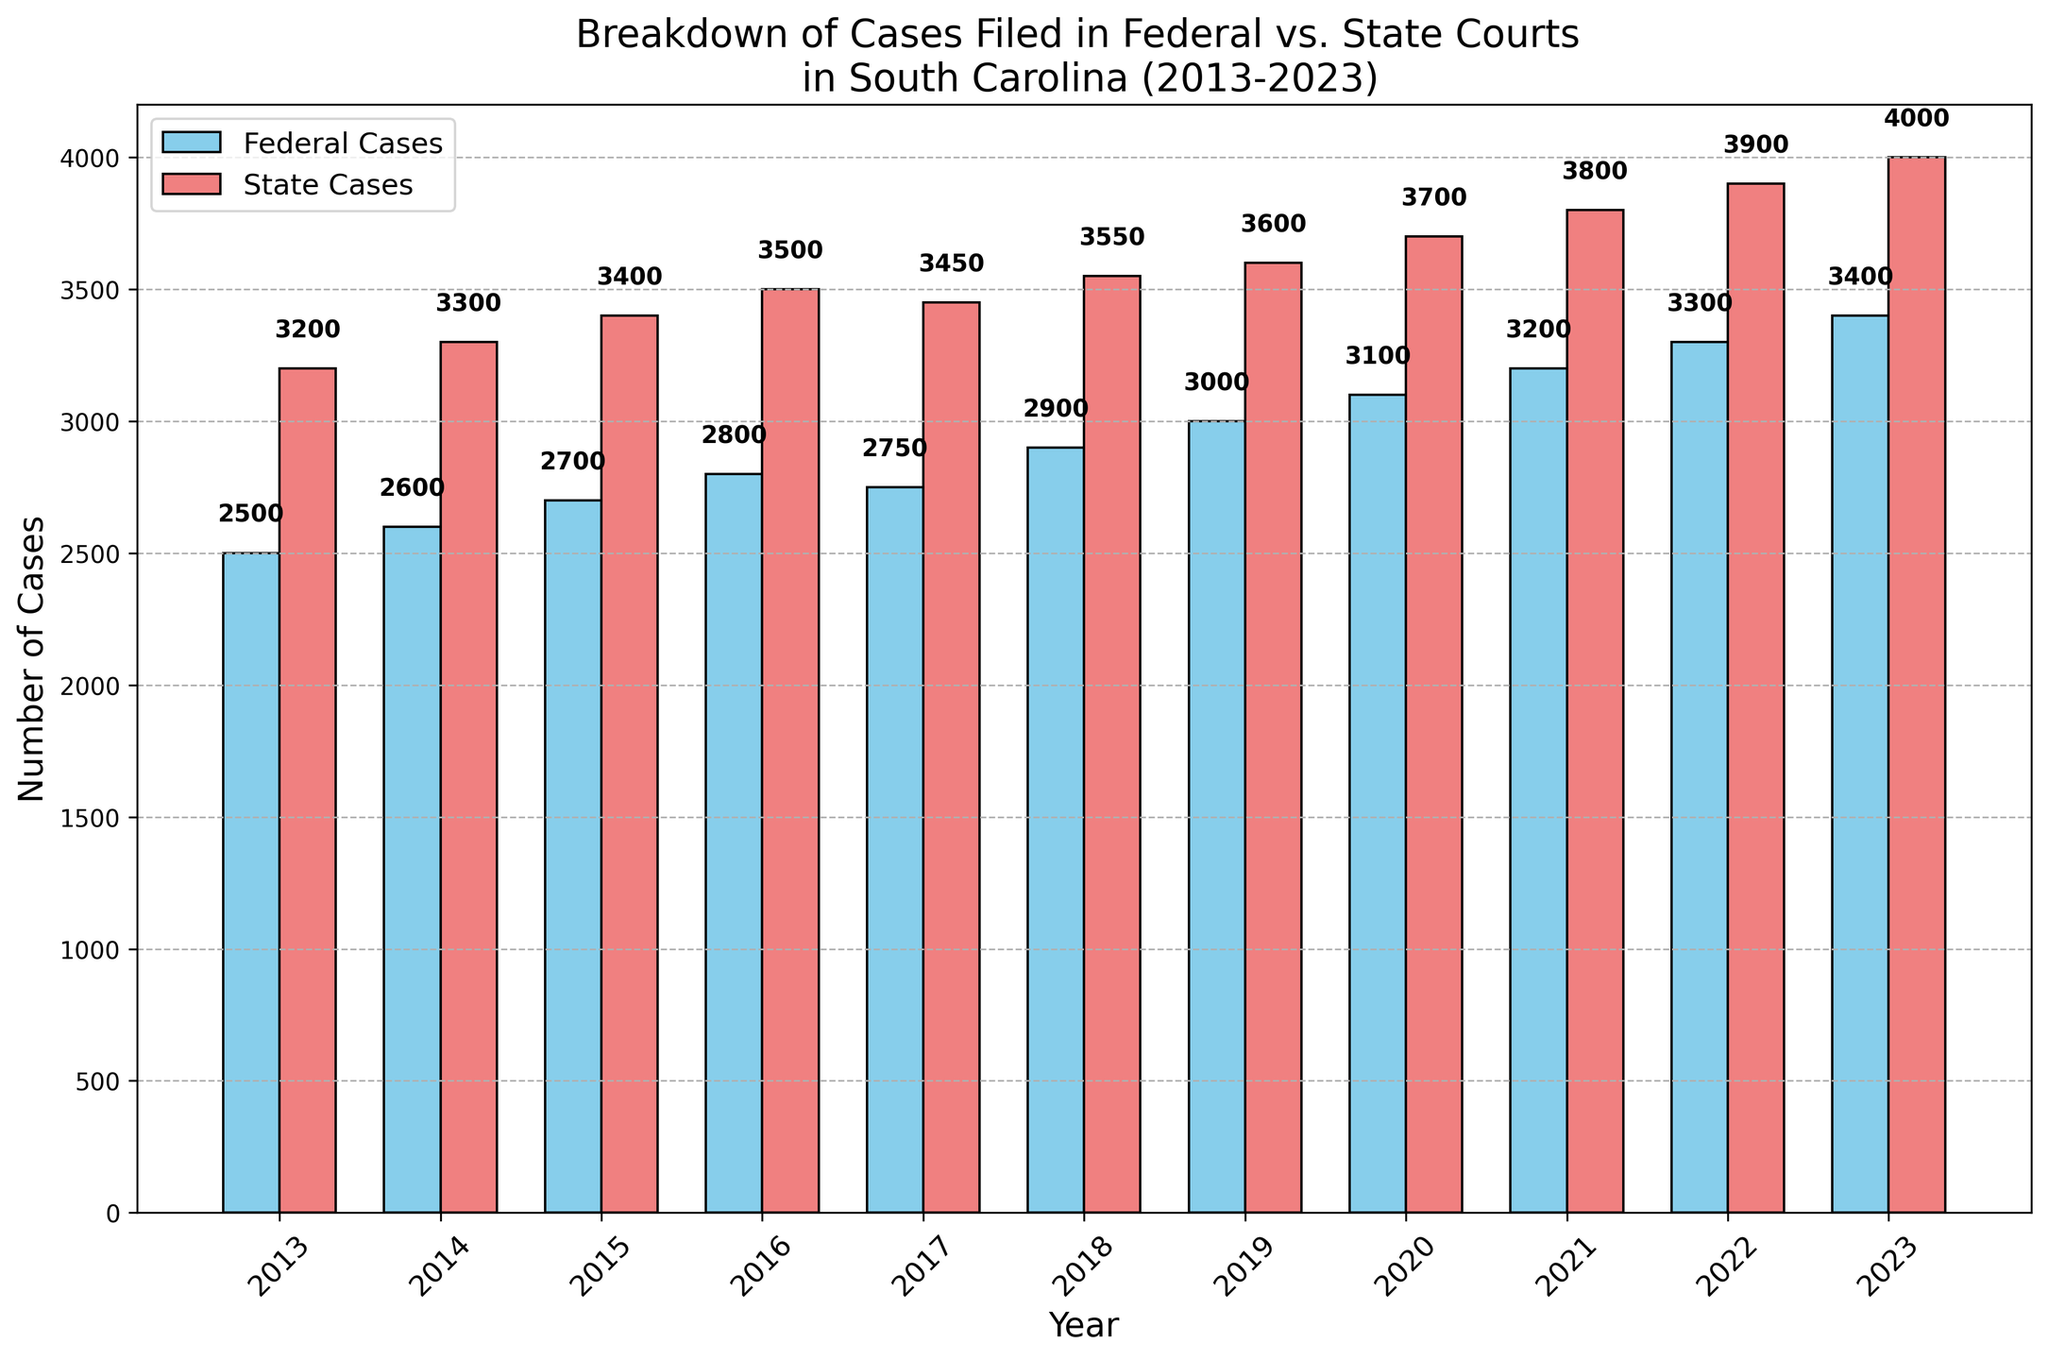Which year had the highest number of federal cases filed? Look at the height of the blue bars for each year and find the tallest one. The tallest blue bar is for the year 2023.
Answer: 2023 How many more state cases were filed than federal cases in 2022? Locate the bars for 2022. The red bar (state cases) is at 3900, and the blue bar (federal cases) is at 3300. Subtract the federal cases from the state cases: 3900 - 3300 = 600.
Answer: 600 In which year were the number of state cases filed exactly 1000 more than the federal cases filed? Compare the height difference between the blue and red bars for each year to see where the difference is exactly 1000. For 2020, federal cases are 3100 and state cases are 3700, making the difference 3700 - 3100 = 1000.
Answer: 2020 Is the number of federal cases in 2019 greater than the number of state cases in 2015? Compare the height of the blue bar in 2019 with the height of the red bar in 2015. The federal cases in 2019 are 3000, while the state cases in 2015 are 3400. 3000 is less than 3400.
Answer: No Which year had the smallest increase in the number of state cases compared to the previous year? Calculate the difference in the height of the red bars between consecutive years. The smallest increase is between 2016 (3500) and 2017 (3450) which is 3450 - 3500 = -50.
Answer: 2017 What is the total number of federal cases filed from 2013 to 2023? Sum the heights of all the blue bars: 2500 + 2600 + 2700 + 2800 + 2750 + 2900 + 3000 + 3100 + 3200 + 3300 + 3400 = 32250.
Answer: 32250 Which category (federal or state cases) saw a more significant increase from 2019 to 2023? Calculate the difference for federal cases from 2019 (3000) to 2023 (3400), which is 3400 - 3000 = 400. For state cases from 2019 (3600) to 2023 (4000), which is 4000 - 3600 = 400. Both had the same increase.
Answer: Both What's the average number of state cases filed per year from 2013 to 2023? Sum the number of state cases and divide by the number of years. (3200 + 3300 + 3400 + 3500 + 3450 + 3550 + 3600 + 3700 + 3800 + 3900 + 4000) / 11 = 3636.36.
Answer: 3636.36 How many total cases (federal + state) were filed in 2017? Add the height of the blue and red bars for 2017. Federal cases = 2750, state cases = 3450, so total cases = 2750 + 3450 = 6200.
Answer: 6200 Is there any year where the number of federal cases is the same as the number of state cases? Look for any year where the heights of the blue and red bars are identical. There is no such year in the chart.
Answer: No 